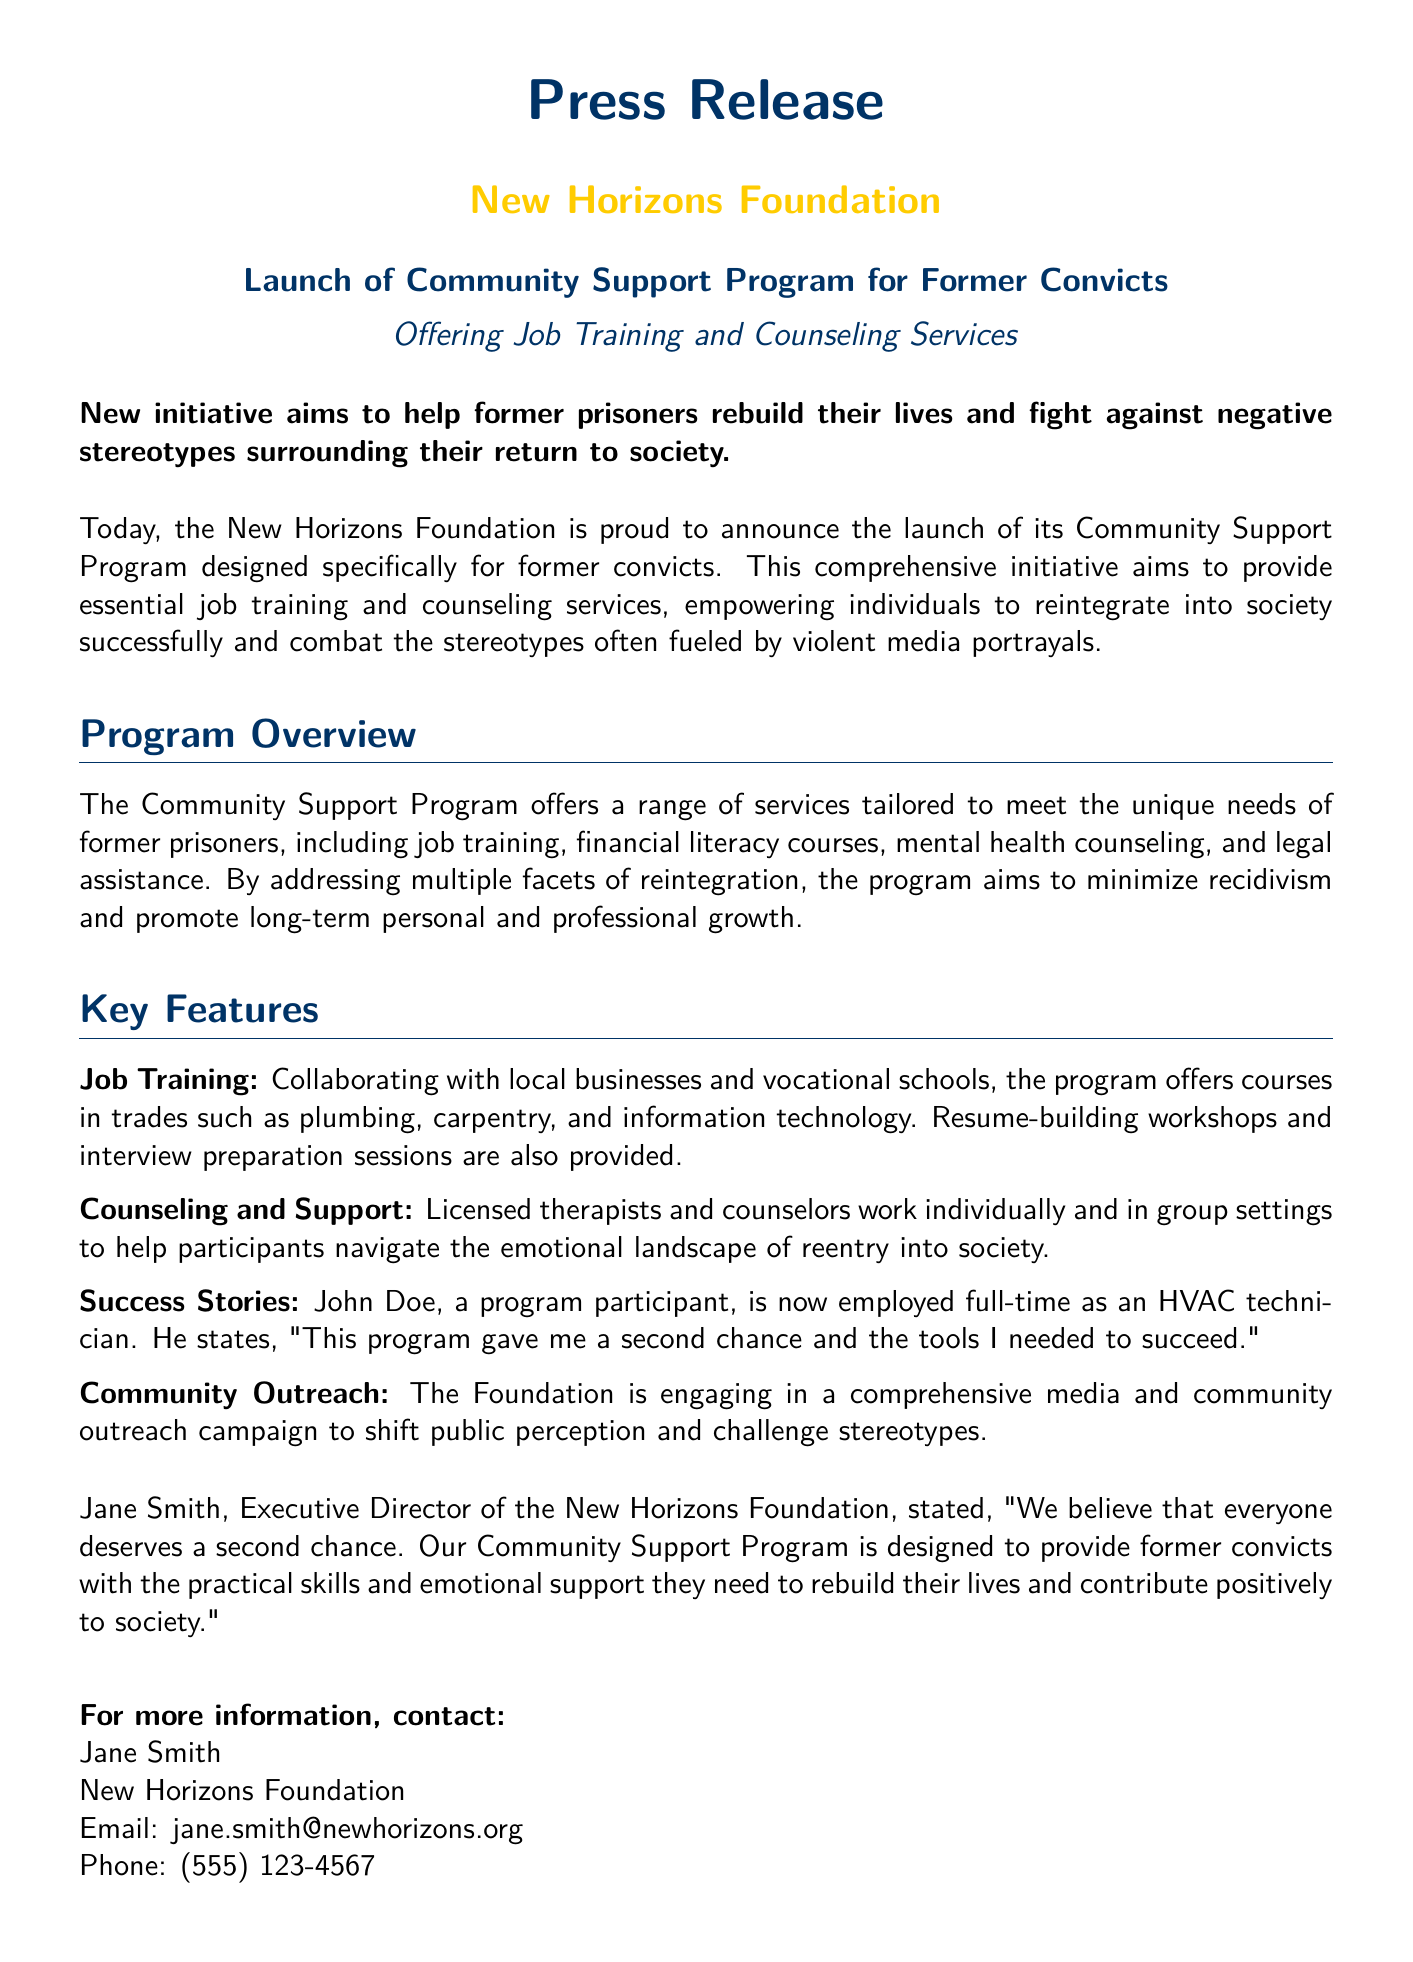What is the name of the foundation launching the program? The foundation's name is mentioned in the press release as the New Horizons Foundation.
Answer: New Horizons Foundation What services are offered by the program? The document lists job training, financial literacy courses, mental health counseling, and legal assistance as the program services.
Answer: Job training and counseling services Who is the Executive Director of the New Horizons Foundation? The press release explicitly states the name of the Executive Director as Jane Smith.
Answer: Jane Smith What trade courses are offered in the job training section? The document outlines plumbing, carpentry, and information technology as the specific trade courses available.
Answer: Plumbing, carpentry, and information technology What does John Doe, a program participant, now work as? His current employment is mentioned in the success stories section, stating he works as an HVAC technician.
Answer: HVAC technician What is the main goal of the Community Support Program? The primary objective stated in the press release is to help former prisoners reintegrate into society and minimize recidivism.
Answer: Reintegrate into society What type of outreach is the foundation engaging in? The document specifies that the New Horizons Foundation is conducting a media and community outreach campaign.
Answer: Media and community outreach How can someone contact Jane Smith? The press release provides Jane Smith's email address and phone number for contact information.
Answer: (555) 123-4567 